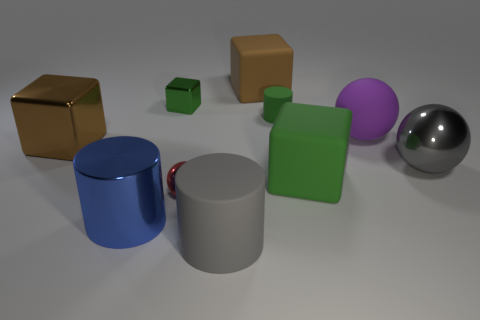There is a big block that is the same color as the tiny matte cylinder; what material is it?
Your answer should be very brief. Rubber. What material is the tiny red object that is the same shape as the gray shiny object?
Your response must be concise. Metal. Is the color of the tiny shiny cube the same as the matte object that is behind the small green metallic thing?
Provide a short and direct response. No. What color is the shiny thing left of the large metal thing in front of the small ball?
Make the answer very short. Brown. Is there any other thing that is the same size as the brown metal object?
Your answer should be compact. Yes. There is a shiny thing behind the purple thing; does it have the same shape as the large brown metal thing?
Your answer should be compact. Yes. How many big matte things are both behind the gray sphere and right of the brown rubber object?
Keep it short and to the point. 1. What is the color of the metallic sphere that is in front of the rubber block that is in front of the tiny metallic thing that is to the left of the red metallic object?
Ensure brevity in your answer.  Red. There is a big brown object that is behind the brown shiny block; how many green cubes are on the right side of it?
Your answer should be compact. 1. What number of other objects are there of the same shape as the big brown metallic object?
Give a very brief answer. 3. 